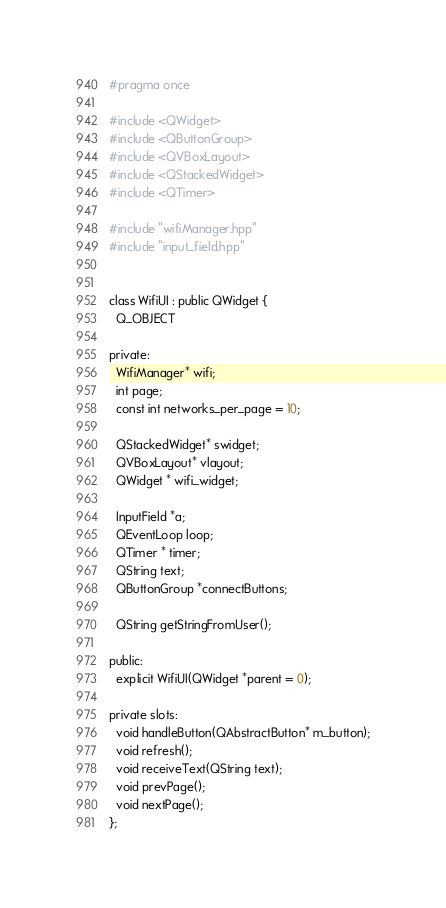Convert code to text. <code><loc_0><loc_0><loc_500><loc_500><_C++_>#pragma once

#include <QWidget>
#include <QButtonGroup>
#include <QVBoxLayout>
#include <QStackedWidget>
#include <QTimer>

#include "wifiManager.hpp"
#include "input_field.hpp"


class WifiUI : public QWidget {
  Q_OBJECT

private:
  WifiManager* wifi;
  int page;
  const int networks_per_page = 10;

  QStackedWidget* swidget;
  QVBoxLayout* vlayout;
  QWidget * wifi_widget;

  InputField *a;
  QEventLoop loop;
  QTimer * timer;
  QString text;
  QButtonGroup *connectButtons;

  QString getStringFromUser();

public:
  explicit WifiUI(QWidget *parent = 0);

private slots:
  void handleButton(QAbstractButton* m_button);
  void refresh();
  void receiveText(QString text);
  void prevPage();
  void nextPage();
};
</code> 